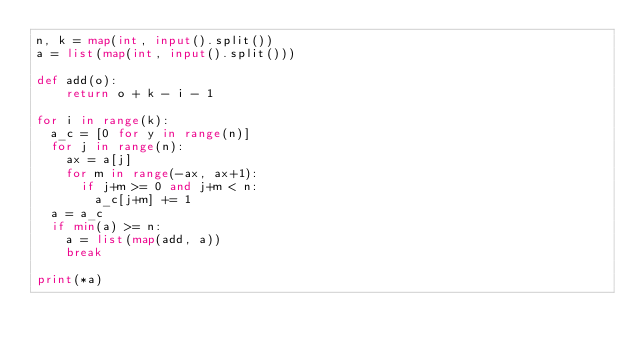Convert code to text. <code><loc_0><loc_0><loc_500><loc_500><_Python_>n, k = map(int, input().split())
a = list(map(int, input().split()))

def add(o):
    return o + k - i - 1

for i in range(k):
  a_c = [0 for y in range(n)]
  for j in range(n):
    ax = a[j]
    for m in range(-ax, ax+1):
      if j+m >= 0 and j+m < n:
        a_c[j+m] += 1
  a = a_c
  if min(a) >= n:
    a = list(map(add, a))
    break

print(*a)
</code> 